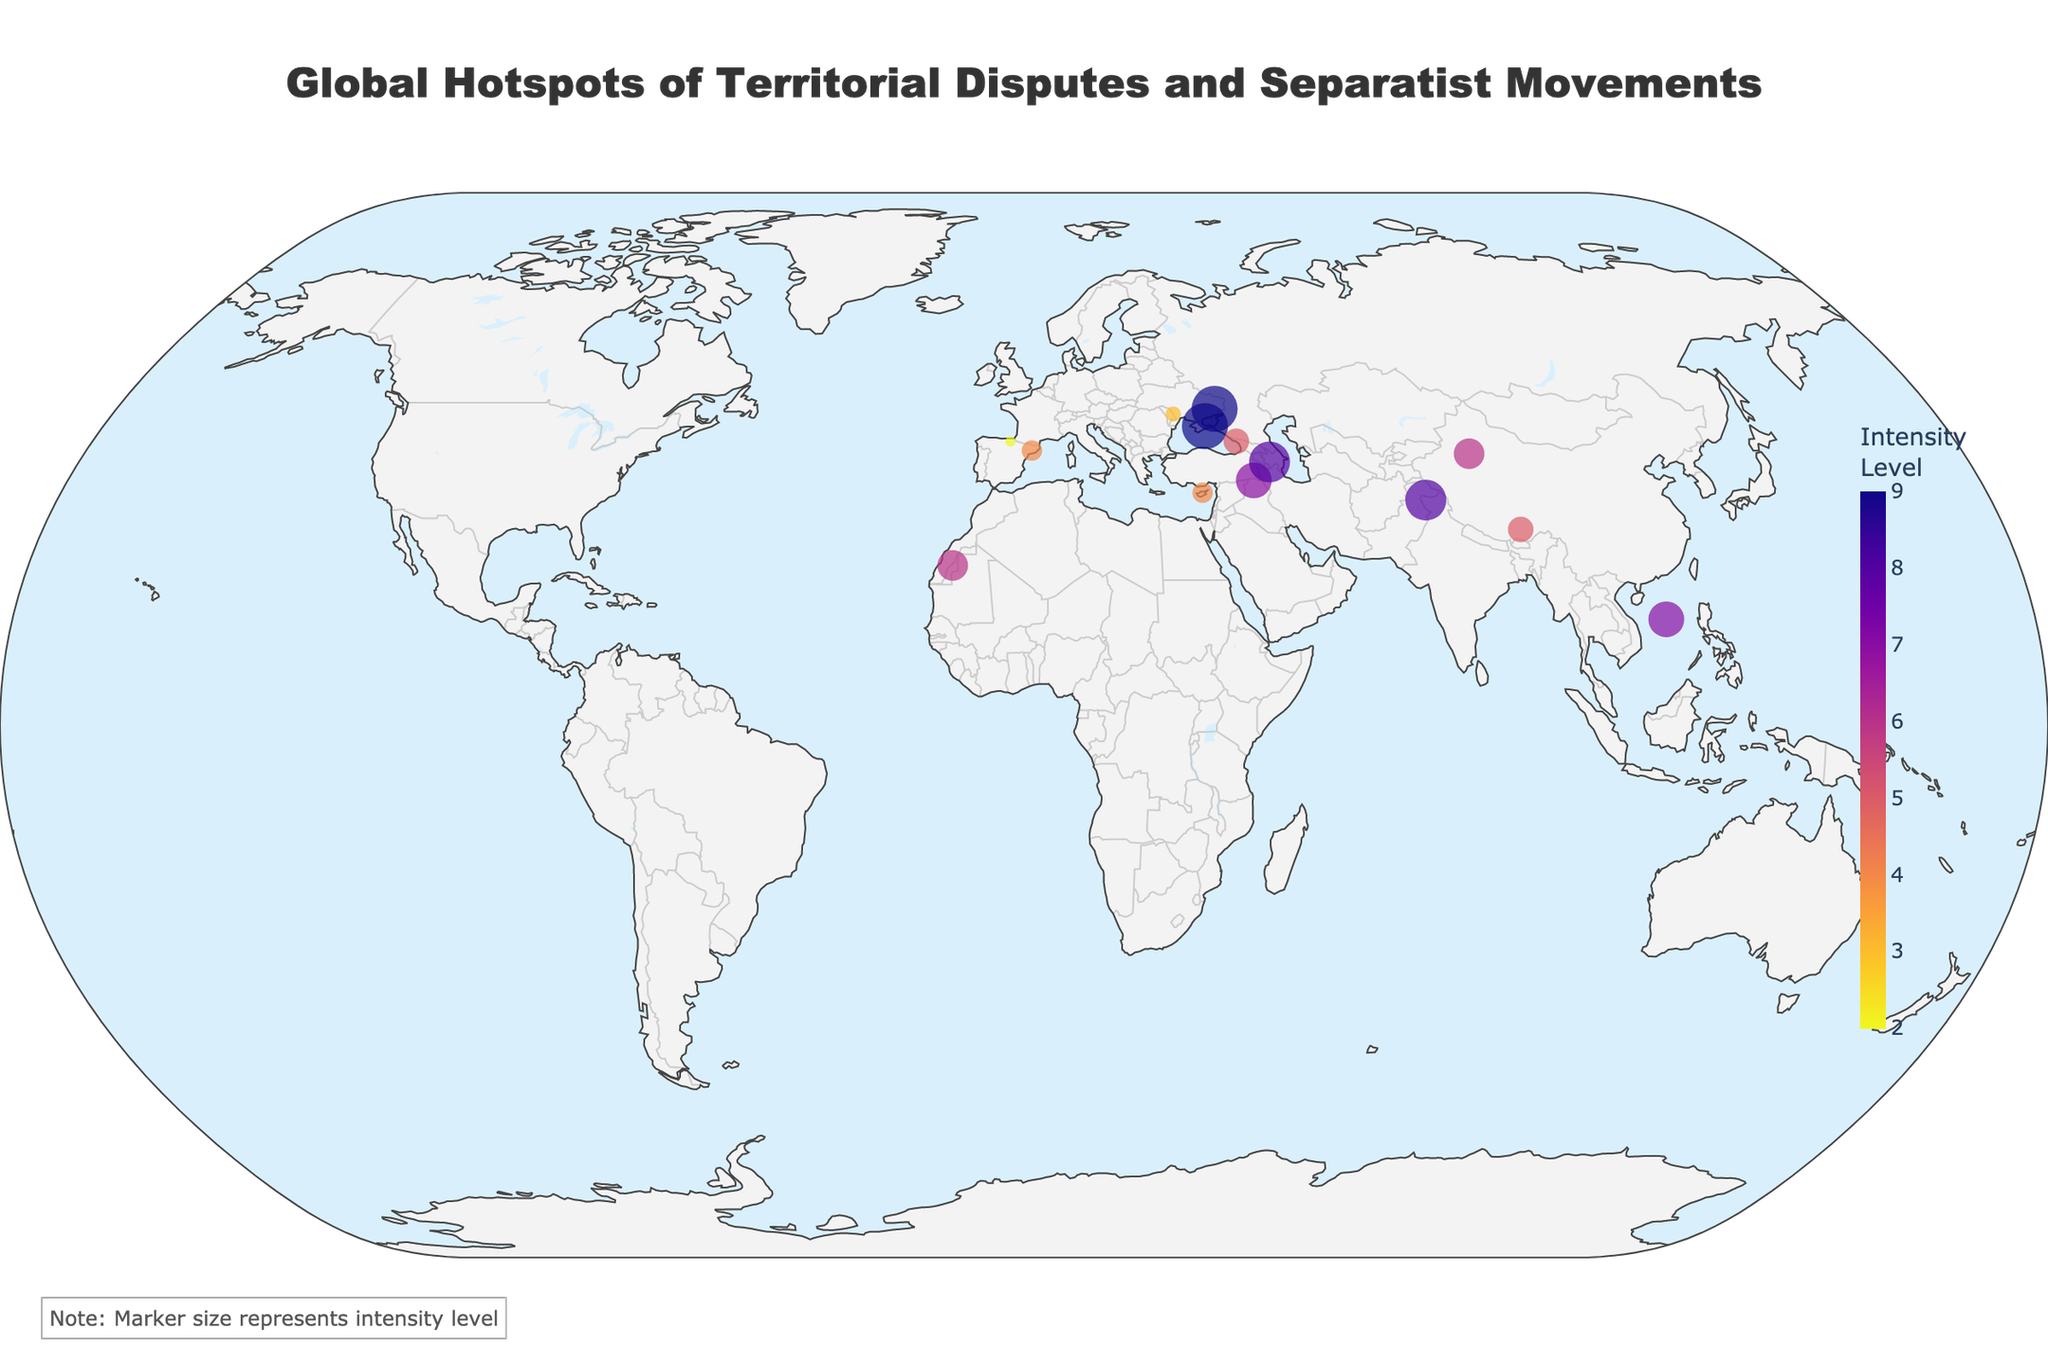What is the title of the figure? The title is usually located at the top of the figure. It is written in a prominent font and readable size, providing a clear description of the figure content. The title is "Global Hotspots of Territorial Disputes and Separatist Movements".
Answer: Global Hotspots of Territorial Disputes and Separatist Movements How is the intensity level represented in the markers on the map? The intensity level is indicated by the size and color of the markers. Larger markers and the color coding provided by the color scale (Plasma) signal higher intensity levels.
Answer: By size and color of the markers Which region has the highest intensity level for a dispute? The figure shows Crimea and Donetsk/Luhansk with the highest intensity levels, represented by the largest and most intensely colored markers. Both have an intensity level of 9.
Answer: Crimea and Donetsk/Luhansk What is the duration of the conflict in Tibet? The tooltip reveals the duration of specific conflicts when hovering over the markers. It shows that the conflict in Tibet has lasted for 72 years.
Answer: 72 years Which region has the longest duration of conflict? Checking the data points reveals that Kurdistan has the longest duration of conflict, 100 years. It is one of the key characteristics revealing itself visibly on the marker tooltips.
Answer: Kurdistan How do the intensity levels of the Kashmir and Nagorno-Karabakh disputes compare? By observing the size and colors of the markers for Kashmir and Nagorno-Karabakh, one can see both regions have intensity levels of 8, meaning their disputes are equally intense.
Answer: They are equal What type of dispute is occurring in Xinjiang? Hovering over the marker for Xinjiang provides detailed information, including the type of dispute. Xinjiang is noted as an autonomy dispute.
Answer: Autonomy Which region has a lower intensity level, Catalonia or Xinjiang? Comparing the marker sizes and colors, Catalonia (4) has a lower intensity level than Xinjiang (6).
Answer: Catalonia Which regions have an intensity level of 7? The markers for South China Sea and Kurdistan both show an intensity level of 7, illustrated by similar sized markers and corresponding colors.
Answer: South China Sea and Kurdistan What is unique about the separatist conflict in Transnistria in terms of intensity level and duration? Observing the marker, Transnistria has an intensity level of 3, which is lower compared to other regions, and the duration is 31 years. This combination of lower intensity and moderate duration is unique among the depicted disputes.
Answer: Intensity level of 3 and duration of 31 years 